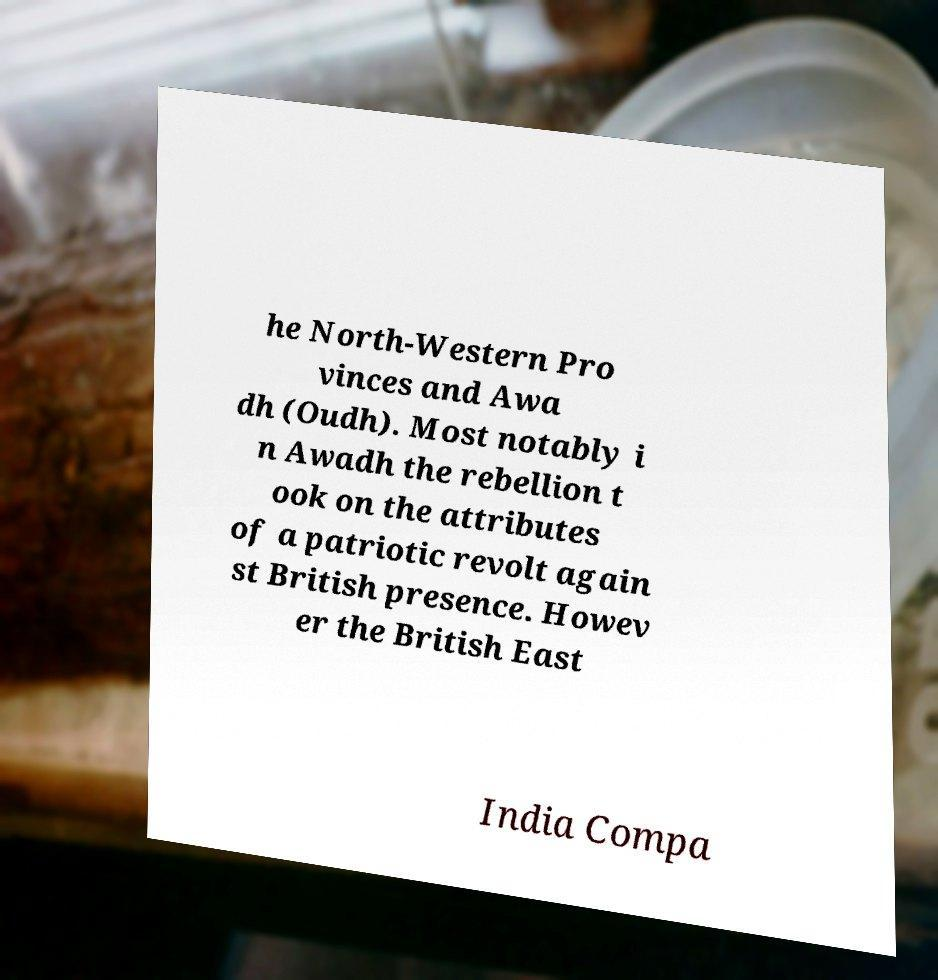Can you accurately transcribe the text from the provided image for me? he North-Western Pro vinces and Awa dh (Oudh). Most notably i n Awadh the rebellion t ook on the attributes of a patriotic revolt again st British presence. Howev er the British East India Compa 